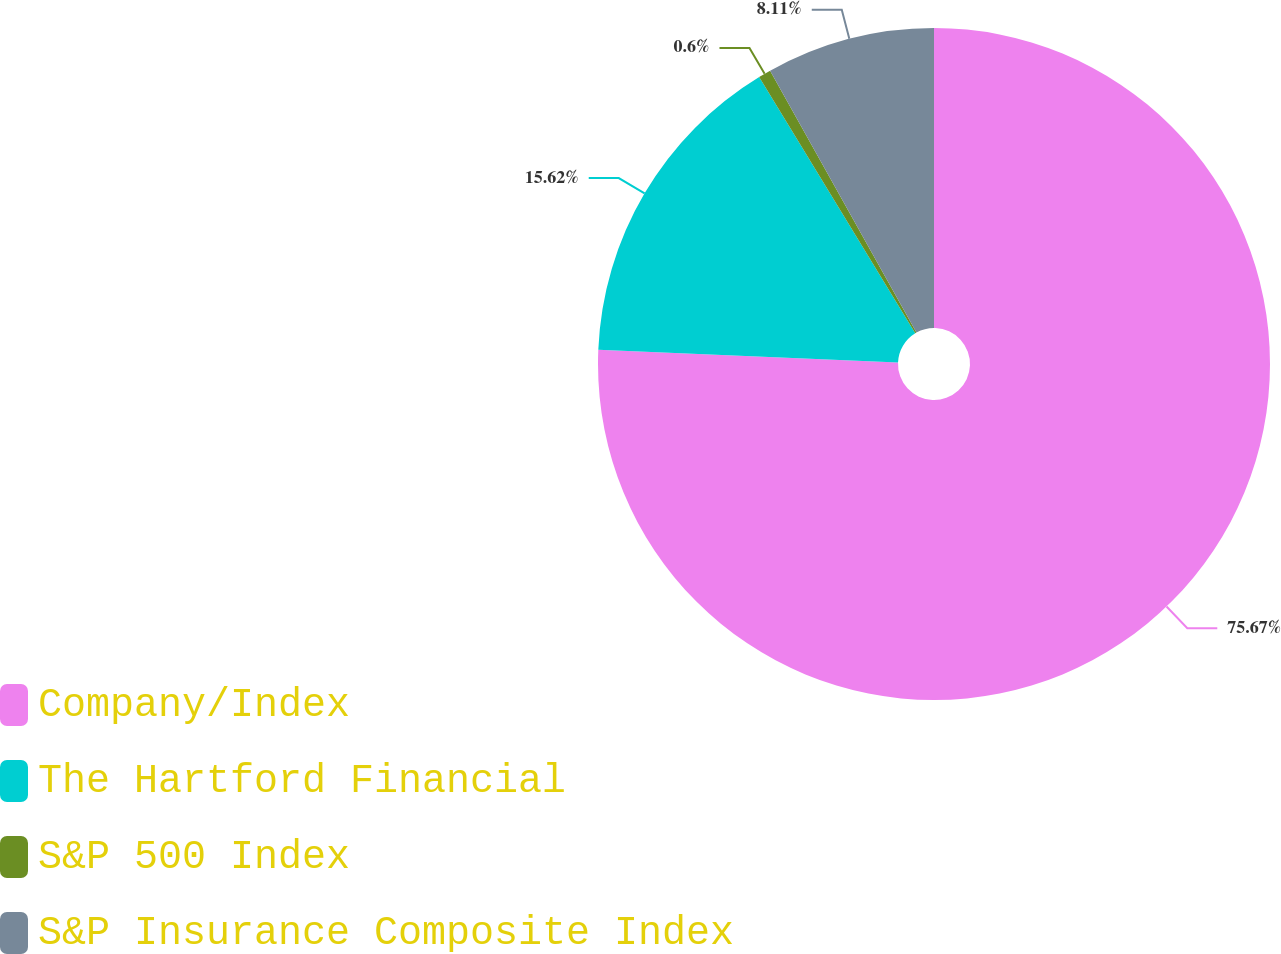Convert chart. <chart><loc_0><loc_0><loc_500><loc_500><pie_chart><fcel>Company/Index<fcel>The Hartford Financial<fcel>S&P 500 Index<fcel>S&P Insurance Composite Index<nl><fcel>75.67%<fcel>15.62%<fcel>0.6%<fcel>8.11%<nl></chart> 